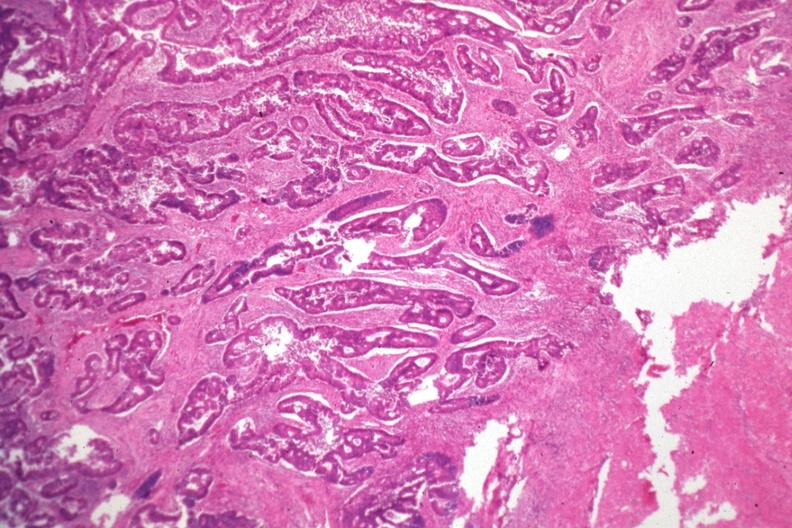s colon present?
Answer the question using a single word or phrase. Yes 